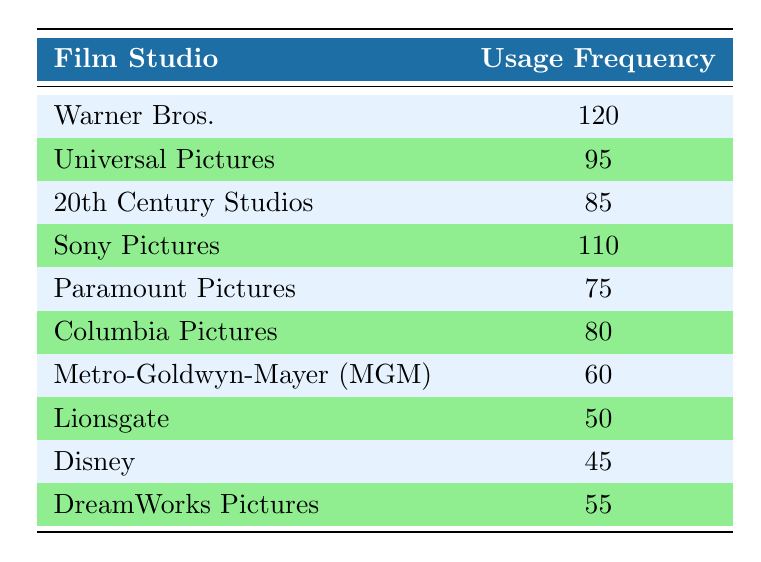What is the usage frequency of Warner Bros.? Warner Bros. is listed in the table with a usage frequency of 120.
Answer: 120 Which studio has the lowest usage frequency? By examining the usage frequencies in the table, Disney has the lowest value at 45.
Answer: Disney What is the total usage frequency for Sony Pictures and Columbia Pictures combined? The usage frequency for Sony Pictures is 110 and for Columbia Pictures is 80. Adding these together, 110 + 80 = 190.
Answer: 190 Is the usage frequency of Universal Pictures greater than that of Lionsgate? Universal Pictures has a usage frequency of 95, while Lionsgate has 50. 95 is indeed greater than 50.
Answer: Yes What is the average usage frequency of the studios listed in the table? There are 10 studios, and their total usage frequency is calculated as: 120 + 95 + 85 + 110 + 75 + 80 + 60 + 50 + 45 + 55 = 775. The average is then 775 divided by 10, which equals 77.5.
Answer: 77.5 How many studios have a usage frequency greater than 60? The studios with usage frequencies greater than 60 are: Warner Bros., Universal Pictures, Sony Pictures, 20th Century Studios, Columbia Pictures, and Metro-Goldwyn-Mayer (MGM), totaling 6 studios.
Answer: 6 What is the difference in usage frequency between Sony Pictures and Paramount Pictures? Sony Pictures has a usage frequency of 110, and Paramount Pictures has 75. The difference is calculated as 110 - 75 = 35.
Answer: 35 Is the usage frequency of DreamWorks Pictures less than that of 20th Century Studios? DreamWorks Pictures has a frequency of 55, while 20th Century Studios has 85. Since 55 is less than 85, the statement is true.
Answer: Yes Which studio has a usage frequency that is exactly the average of Disney and Liongate? Disney has a frequency of 45 and Lionsgate has 50. The average of these two is (45 + 50) / 2 = 47.5. Checking the table, no studio has this exact frequency.
Answer: No 